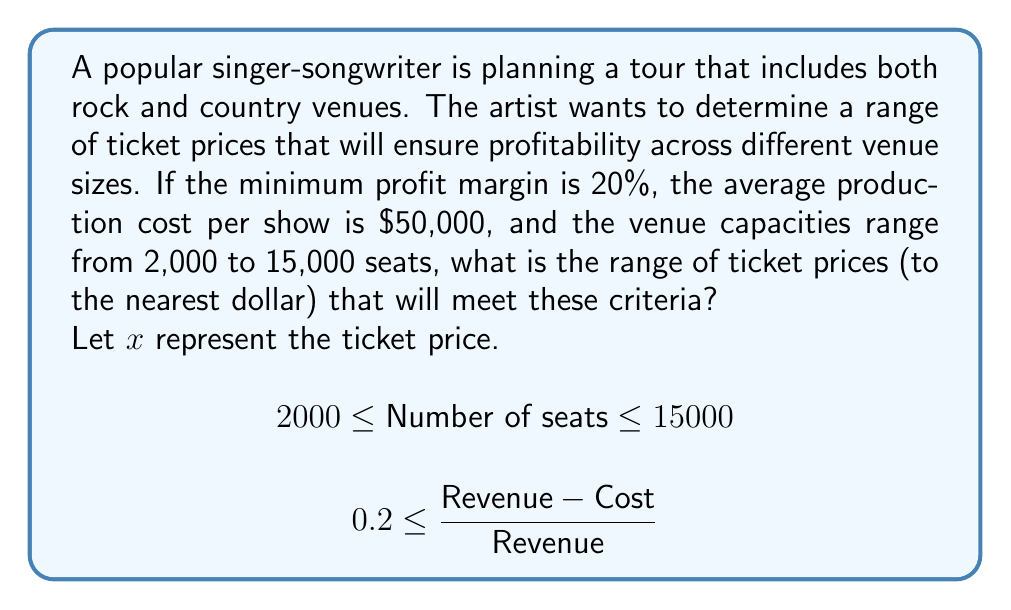What is the answer to this math problem? 1. Set up the inequality for the profit margin:
   $$0.2 \leq \frac{\text{Revenue} - \text{Cost}}{\text{Revenue}}$$

2. Express revenue in terms of ticket price and number of seats:
   $$0.2 \leq \frac{x \cdot \text{seats} - 50000}{x \cdot \text{seats}}$$

3. Solve the inequality for the minimum ticket price (using 2,000 seats):
   $$0.2 \leq \frac{2000x - 50000}{2000x}$$
   $$0.2 \cdot 2000x \leq 2000x - 50000$$
   $$400x \leq 2000x - 50000$$
   $$50000 \leq 1600x$$
   $$x \geq 31.25$$

4. Solve the inequality for the maximum ticket price (using 15,000 seats):
   $$0.2 \leq \frac{15000x - 50000}{15000x}$$
   $$0.2 \cdot 15000x \leq 15000x - 50000$$
   $$3000x \leq 15000x - 50000$$
   $$50000 \leq 12000x$$
   $$x \geq 4.17$$

5. Round the minimum ticket price up to the nearest dollar: $32

6. The maximum ticket price is not constrained by the given conditions, but should be set based on market factors. For this question, we'll assume a reasonable maximum of $150.
Answer: $32 to $150 